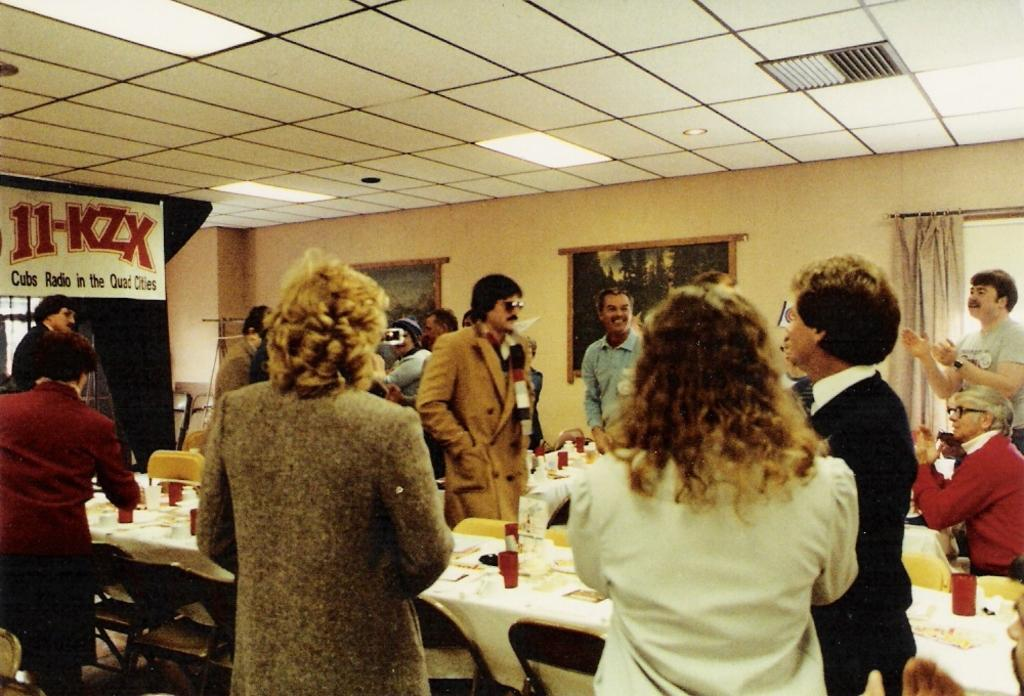What can be seen in the image? There are people standing in the image. What object is present in the image besides the people? There is a table in the image. What type of frame is surrounding the people in the image? There is no frame surrounding the people in the image; it is a photograph or illustration without a frame. What disease can be seen affecting the people in the image? There is no disease visible in the image; it only shows people standing. 